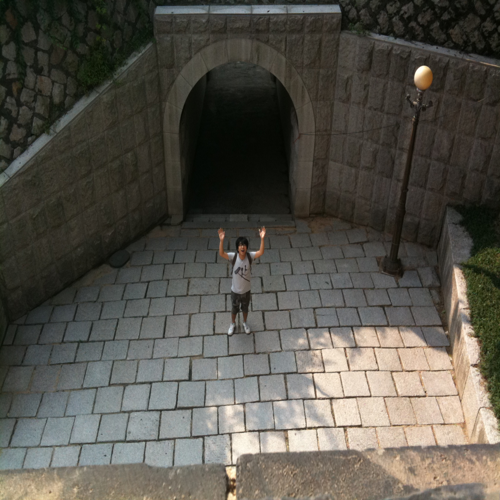Is the lighting a little weak? Yes, the lighting does appear to be somewhat weak, particularly within the tunnel where the shadows are more pronounced, creating a stark contrast with the brighter areas outside. 